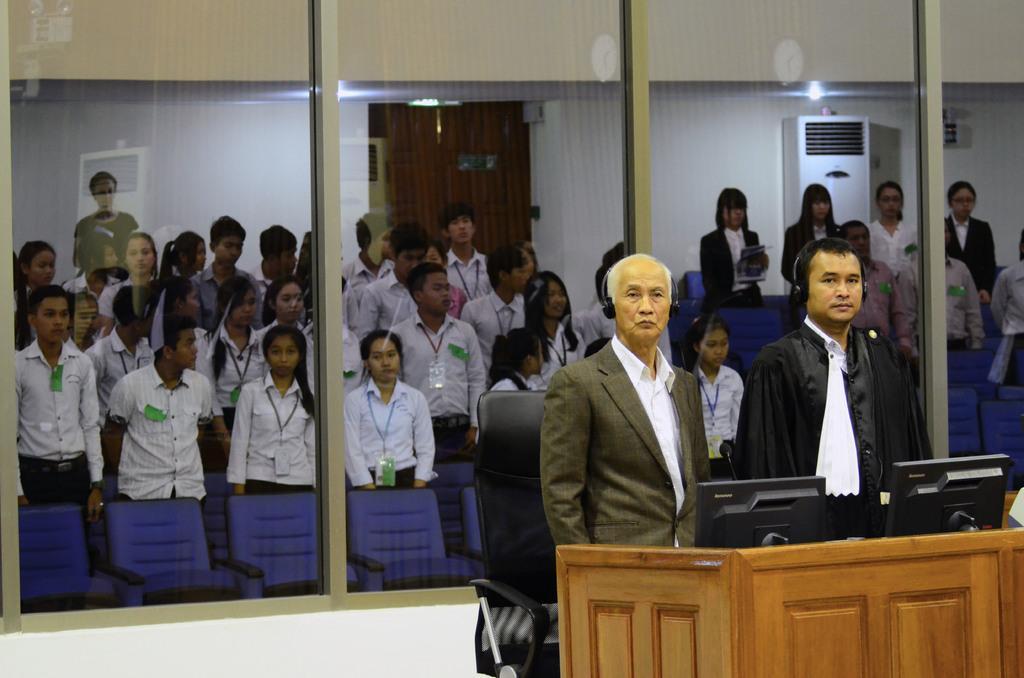Please provide a concise description of this image. In this image I see number of people who are standing and I see the chairs which are of blue and black in color and I see the monitors over here and I see the table over here and I see the transparent glasses. In the background I see the wall and an electronic device over here and I see the lights. 